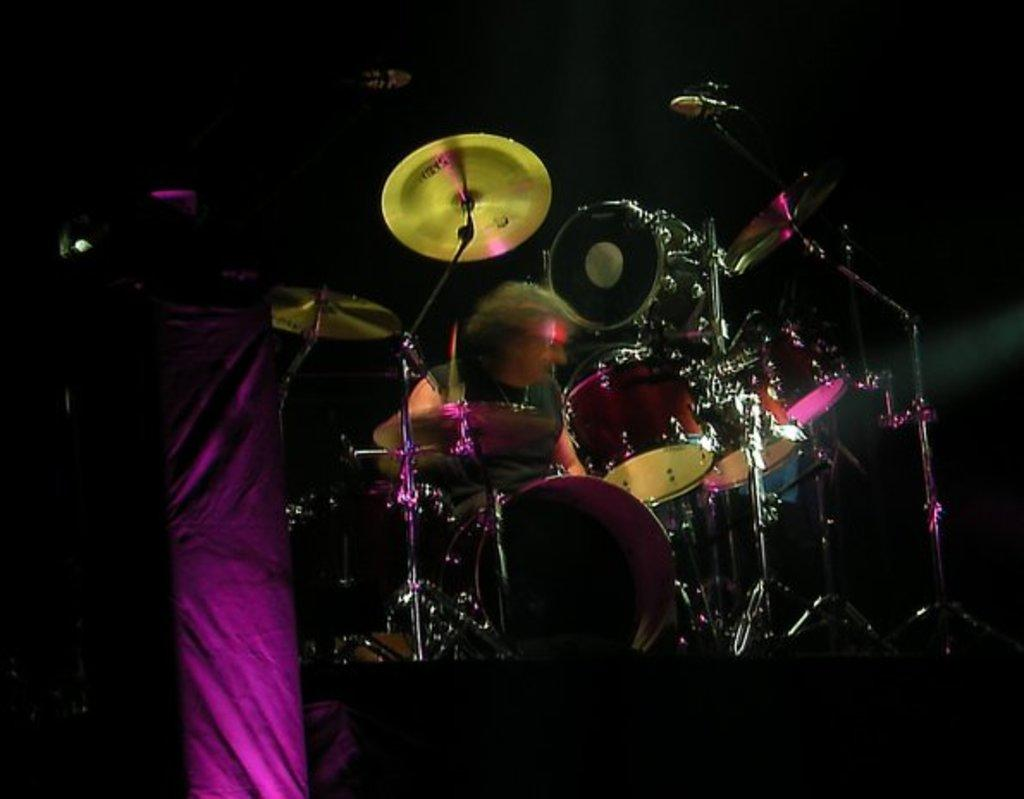What musical instrument is featured in the image? There is a drum set in the image. Who is associated with the drum set in the image? There is a man sitting behind the drum set. What type of toy can be seen in the image? There is no toy present in the image; it features a drum set and a man sitting behind it. Is there any blood visible in the image? No, there is no blood visible in the image. 